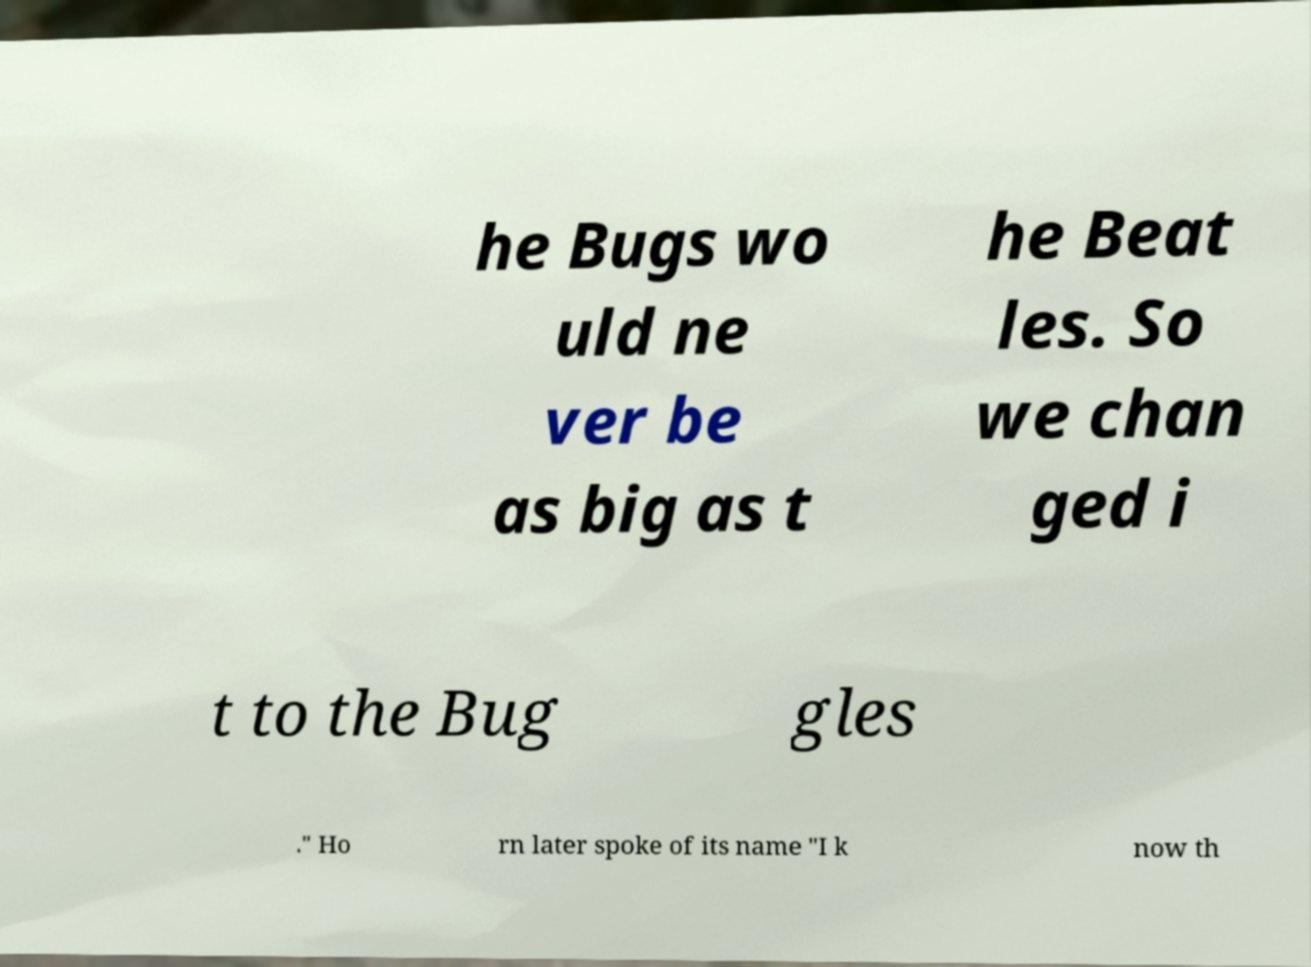Please identify and transcribe the text found in this image. he Bugs wo uld ne ver be as big as t he Beat les. So we chan ged i t to the Bug gles ." Ho rn later spoke of its name "I k now th 